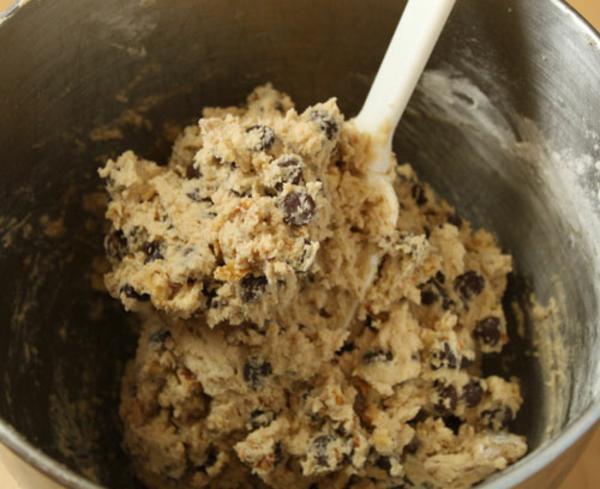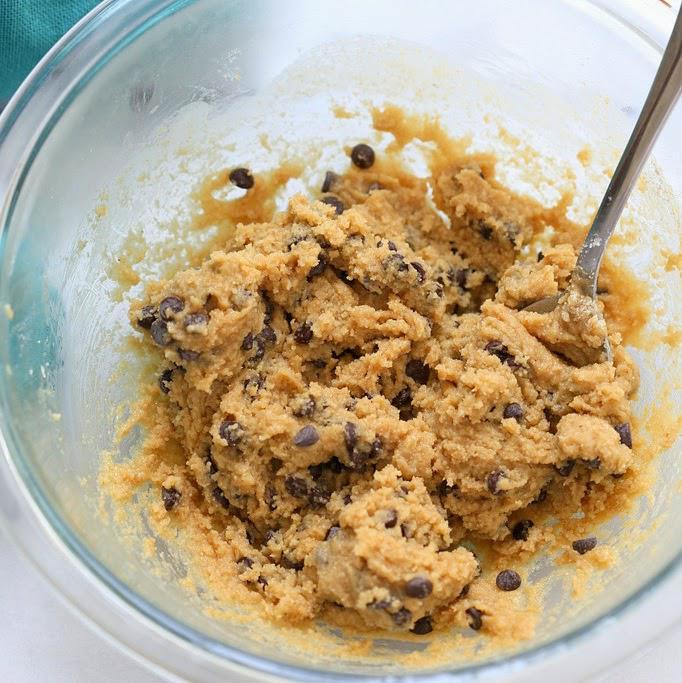The first image is the image on the left, the second image is the image on the right. Assess this claim about the two images: "Each image shows cookie dough in a bowl with the handle of a utensil sticking out of it.". Correct or not? Answer yes or no. Yes. 